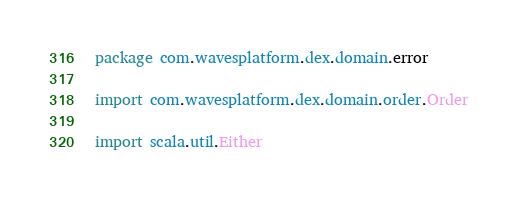Convert code to text. <code><loc_0><loc_0><loc_500><loc_500><_Scala_>package com.wavesplatform.dex.domain.error

import com.wavesplatform.dex.domain.order.Order

import scala.util.Either
</code> 